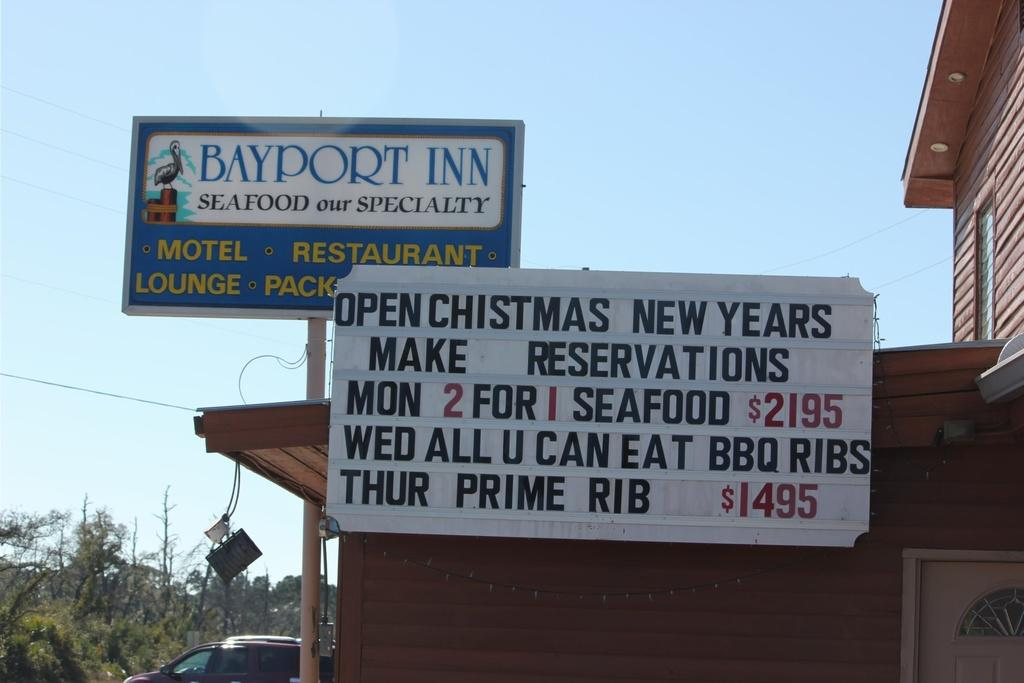Provide a one-sentence caption for the provided image. A hotel sign that says Bayport Inn Seafood our Specialty. 